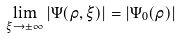Convert formula to latex. <formula><loc_0><loc_0><loc_500><loc_500>\lim _ { \xi \to \pm \infty } | \Psi ( \rho , \xi ) | = | \Psi _ { 0 } ( \rho ) |</formula> 